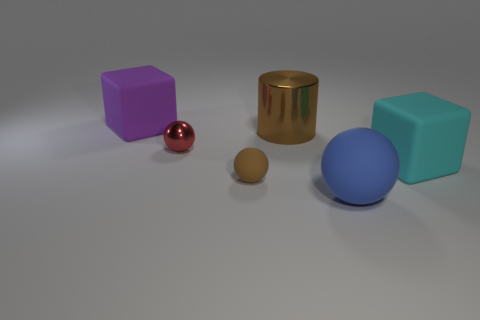There is a matte thing behind the rubber cube that is in front of the matte thing to the left of the tiny brown rubber ball; how big is it?
Your answer should be very brief. Large. What number of other things are there of the same color as the tiny matte object?
Provide a succinct answer. 1. Do the object that is to the right of the large blue rubber ball and the big matte sphere have the same color?
Ensure brevity in your answer.  No. What number of things are tiny yellow blocks or big objects?
Keep it short and to the point. 4. There is a cube to the left of the brown rubber object; what is its color?
Offer a terse response. Purple. Is the number of tiny metal balls in front of the blue rubber ball less than the number of red shiny objects?
Give a very brief answer. Yes. What is the size of the thing that is the same color as the shiny cylinder?
Ensure brevity in your answer.  Small. Is there anything else that has the same size as the cylinder?
Your response must be concise. Yes. Are the cylinder and the red thing made of the same material?
Give a very brief answer. Yes. How many things are blocks that are in front of the purple cube or rubber objects that are in front of the purple object?
Give a very brief answer. 3. 